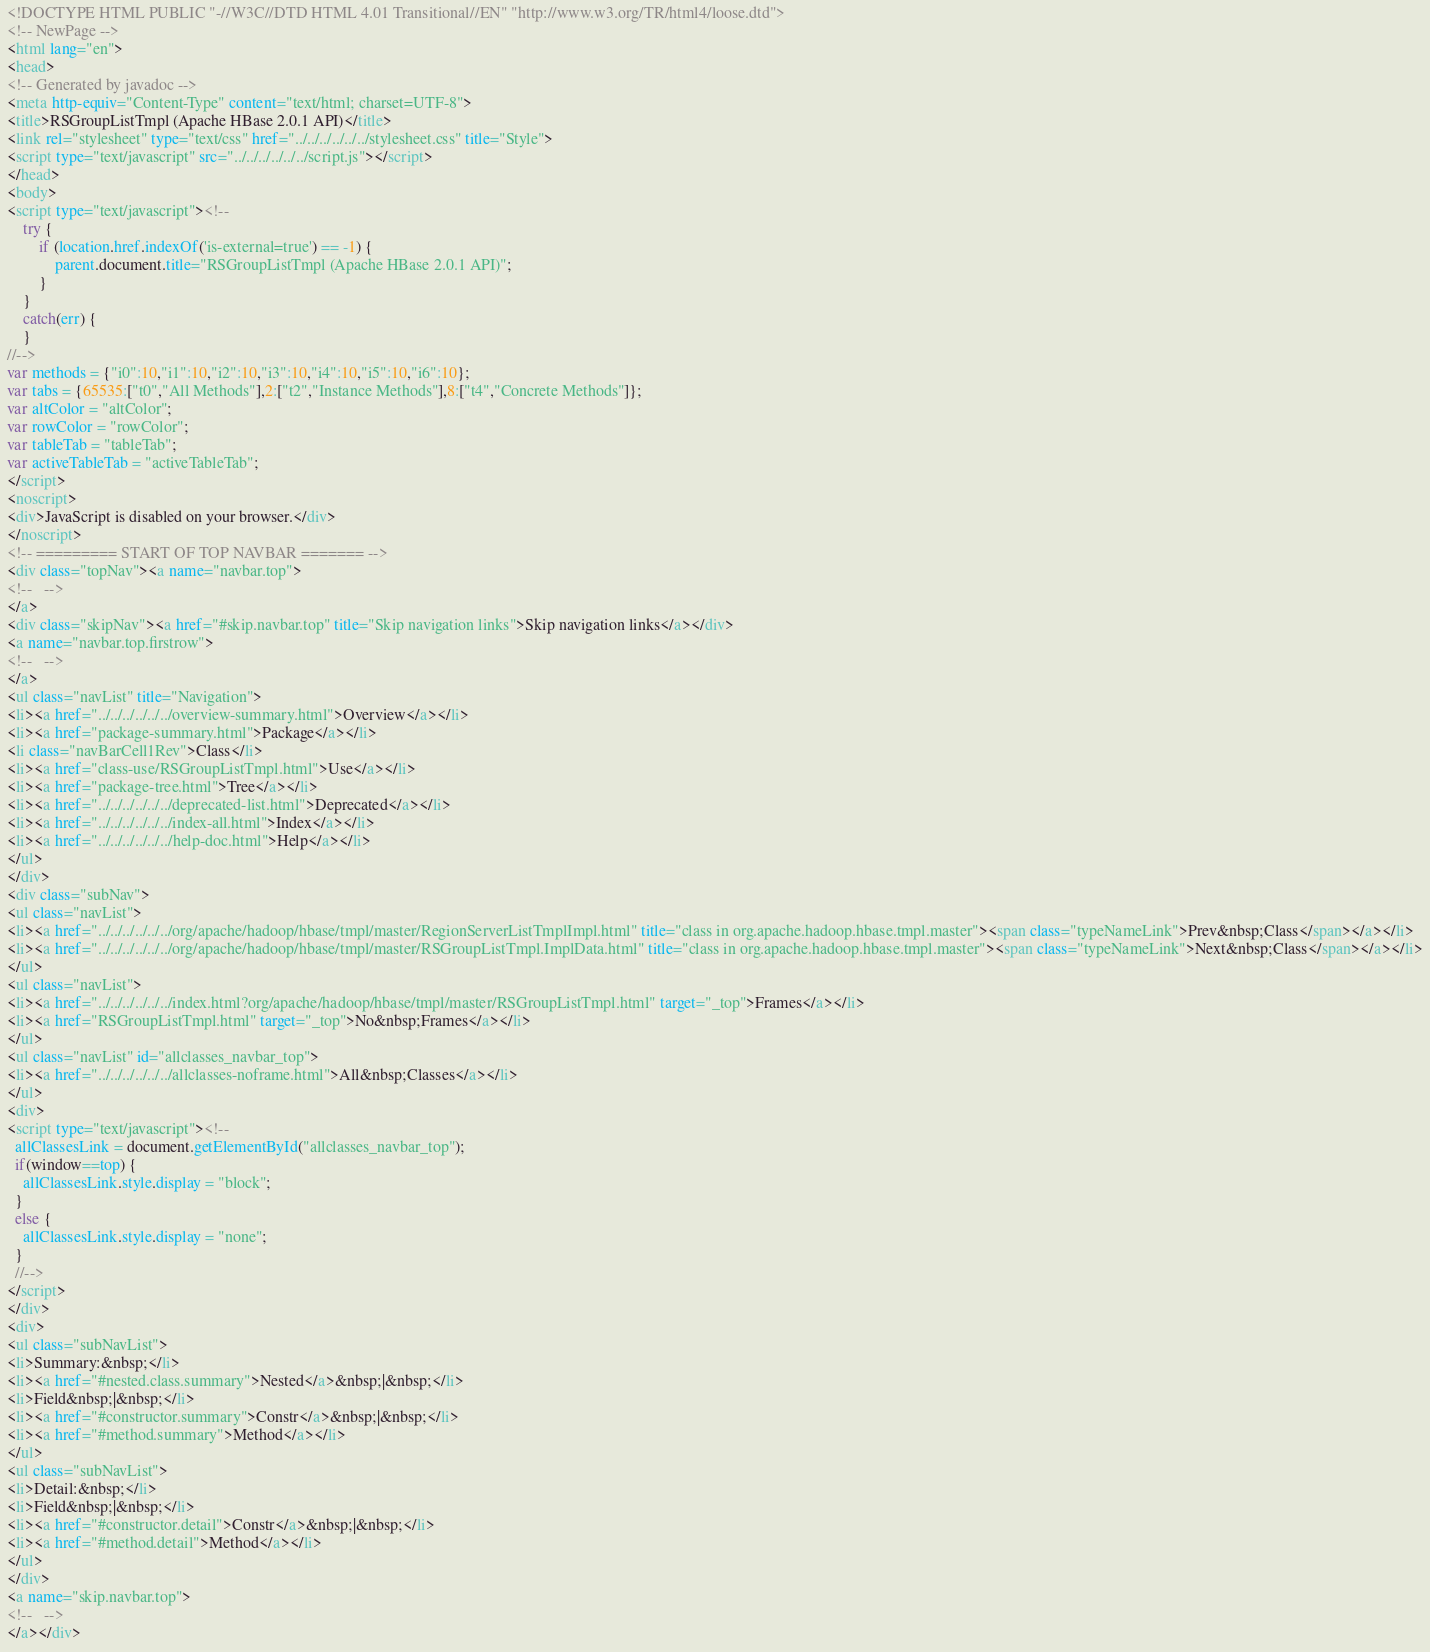Convert code to text. <code><loc_0><loc_0><loc_500><loc_500><_HTML_><!DOCTYPE HTML PUBLIC "-//W3C//DTD HTML 4.01 Transitional//EN" "http://www.w3.org/TR/html4/loose.dtd">
<!-- NewPage -->
<html lang="en">
<head>
<!-- Generated by javadoc -->
<meta http-equiv="Content-Type" content="text/html; charset=UTF-8">
<title>RSGroupListTmpl (Apache HBase 2.0.1 API)</title>
<link rel="stylesheet" type="text/css" href="../../../../../../stylesheet.css" title="Style">
<script type="text/javascript" src="../../../../../../script.js"></script>
</head>
<body>
<script type="text/javascript"><!--
    try {
        if (location.href.indexOf('is-external=true') == -1) {
            parent.document.title="RSGroupListTmpl (Apache HBase 2.0.1 API)";
        }
    }
    catch(err) {
    }
//-->
var methods = {"i0":10,"i1":10,"i2":10,"i3":10,"i4":10,"i5":10,"i6":10};
var tabs = {65535:["t0","All Methods"],2:["t2","Instance Methods"],8:["t4","Concrete Methods"]};
var altColor = "altColor";
var rowColor = "rowColor";
var tableTab = "tableTab";
var activeTableTab = "activeTableTab";
</script>
<noscript>
<div>JavaScript is disabled on your browser.</div>
</noscript>
<!-- ========= START OF TOP NAVBAR ======= -->
<div class="topNav"><a name="navbar.top">
<!--   -->
</a>
<div class="skipNav"><a href="#skip.navbar.top" title="Skip navigation links">Skip navigation links</a></div>
<a name="navbar.top.firstrow">
<!--   -->
</a>
<ul class="navList" title="Navigation">
<li><a href="../../../../../../overview-summary.html">Overview</a></li>
<li><a href="package-summary.html">Package</a></li>
<li class="navBarCell1Rev">Class</li>
<li><a href="class-use/RSGroupListTmpl.html">Use</a></li>
<li><a href="package-tree.html">Tree</a></li>
<li><a href="../../../../../../deprecated-list.html">Deprecated</a></li>
<li><a href="../../../../../../index-all.html">Index</a></li>
<li><a href="../../../../../../help-doc.html">Help</a></li>
</ul>
</div>
<div class="subNav">
<ul class="navList">
<li><a href="../../../../../../org/apache/hadoop/hbase/tmpl/master/RegionServerListTmplImpl.html" title="class in org.apache.hadoop.hbase.tmpl.master"><span class="typeNameLink">Prev&nbsp;Class</span></a></li>
<li><a href="../../../../../../org/apache/hadoop/hbase/tmpl/master/RSGroupListTmpl.ImplData.html" title="class in org.apache.hadoop.hbase.tmpl.master"><span class="typeNameLink">Next&nbsp;Class</span></a></li>
</ul>
<ul class="navList">
<li><a href="../../../../../../index.html?org/apache/hadoop/hbase/tmpl/master/RSGroupListTmpl.html" target="_top">Frames</a></li>
<li><a href="RSGroupListTmpl.html" target="_top">No&nbsp;Frames</a></li>
</ul>
<ul class="navList" id="allclasses_navbar_top">
<li><a href="../../../../../../allclasses-noframe.html">All&nbsp;Classes</a></li>
</ul>
<div>
<script type="text/javascript"><!--
  allClassesLink = document.getElementById("allclasses_navbar_top");
  if(window==top) {
    allClassesLink.style.display = "block";
  }
  else {
    allClassesLink.style.display = "none";
  }
  //-->
</script>
</div>
<div>
<ul class="subNavList">
<li>Summary:&nbsp;</li>
<li><a href="#nested.class.summary">Nested</a>&nbsp;|&nbsp;</li>
<li>Field&nbsp;|&nbsp;</li>
<li><a href="#constructor.summary">Constr</a>&nbsp;|&nbsp;</li>
<li><a href="#method.summary">Method</a></li>
</ul>
<ul class="subNavList">
<li>Detail:&nbsp;</li>
<li>Field&nbsp;|&nbsp;</li>
<li><a href="#constructor.detail">Constr</a>&nbsp;|&nbsp;</li>
<li><a href="#method.detail">Method</a></li>
</ul>
</div>
<a name="skip.navbar.top">
<!--   -->
</a></div></code> 